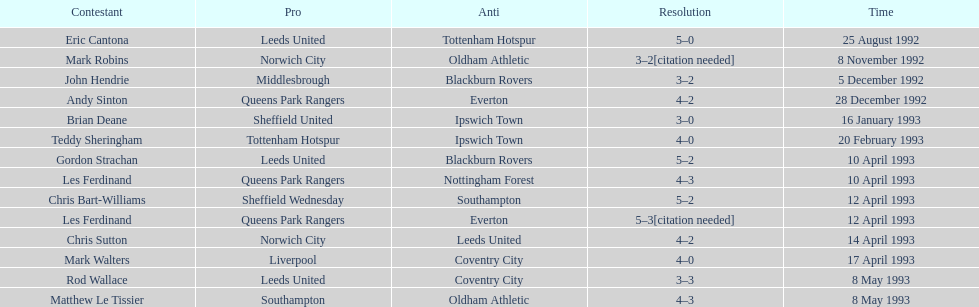Who does john hendrie play for? Middlesbrough. 